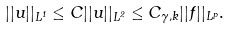<formula> <loc_0><loc_0><loc_500><loc_500>| | u | | _ { L ^ { 1 } } \leq C | | u | | _ { L ^ { 2 } } \leq C _ { \gamma , k } | | f | | _ { L ^ { p } } .</formula> 